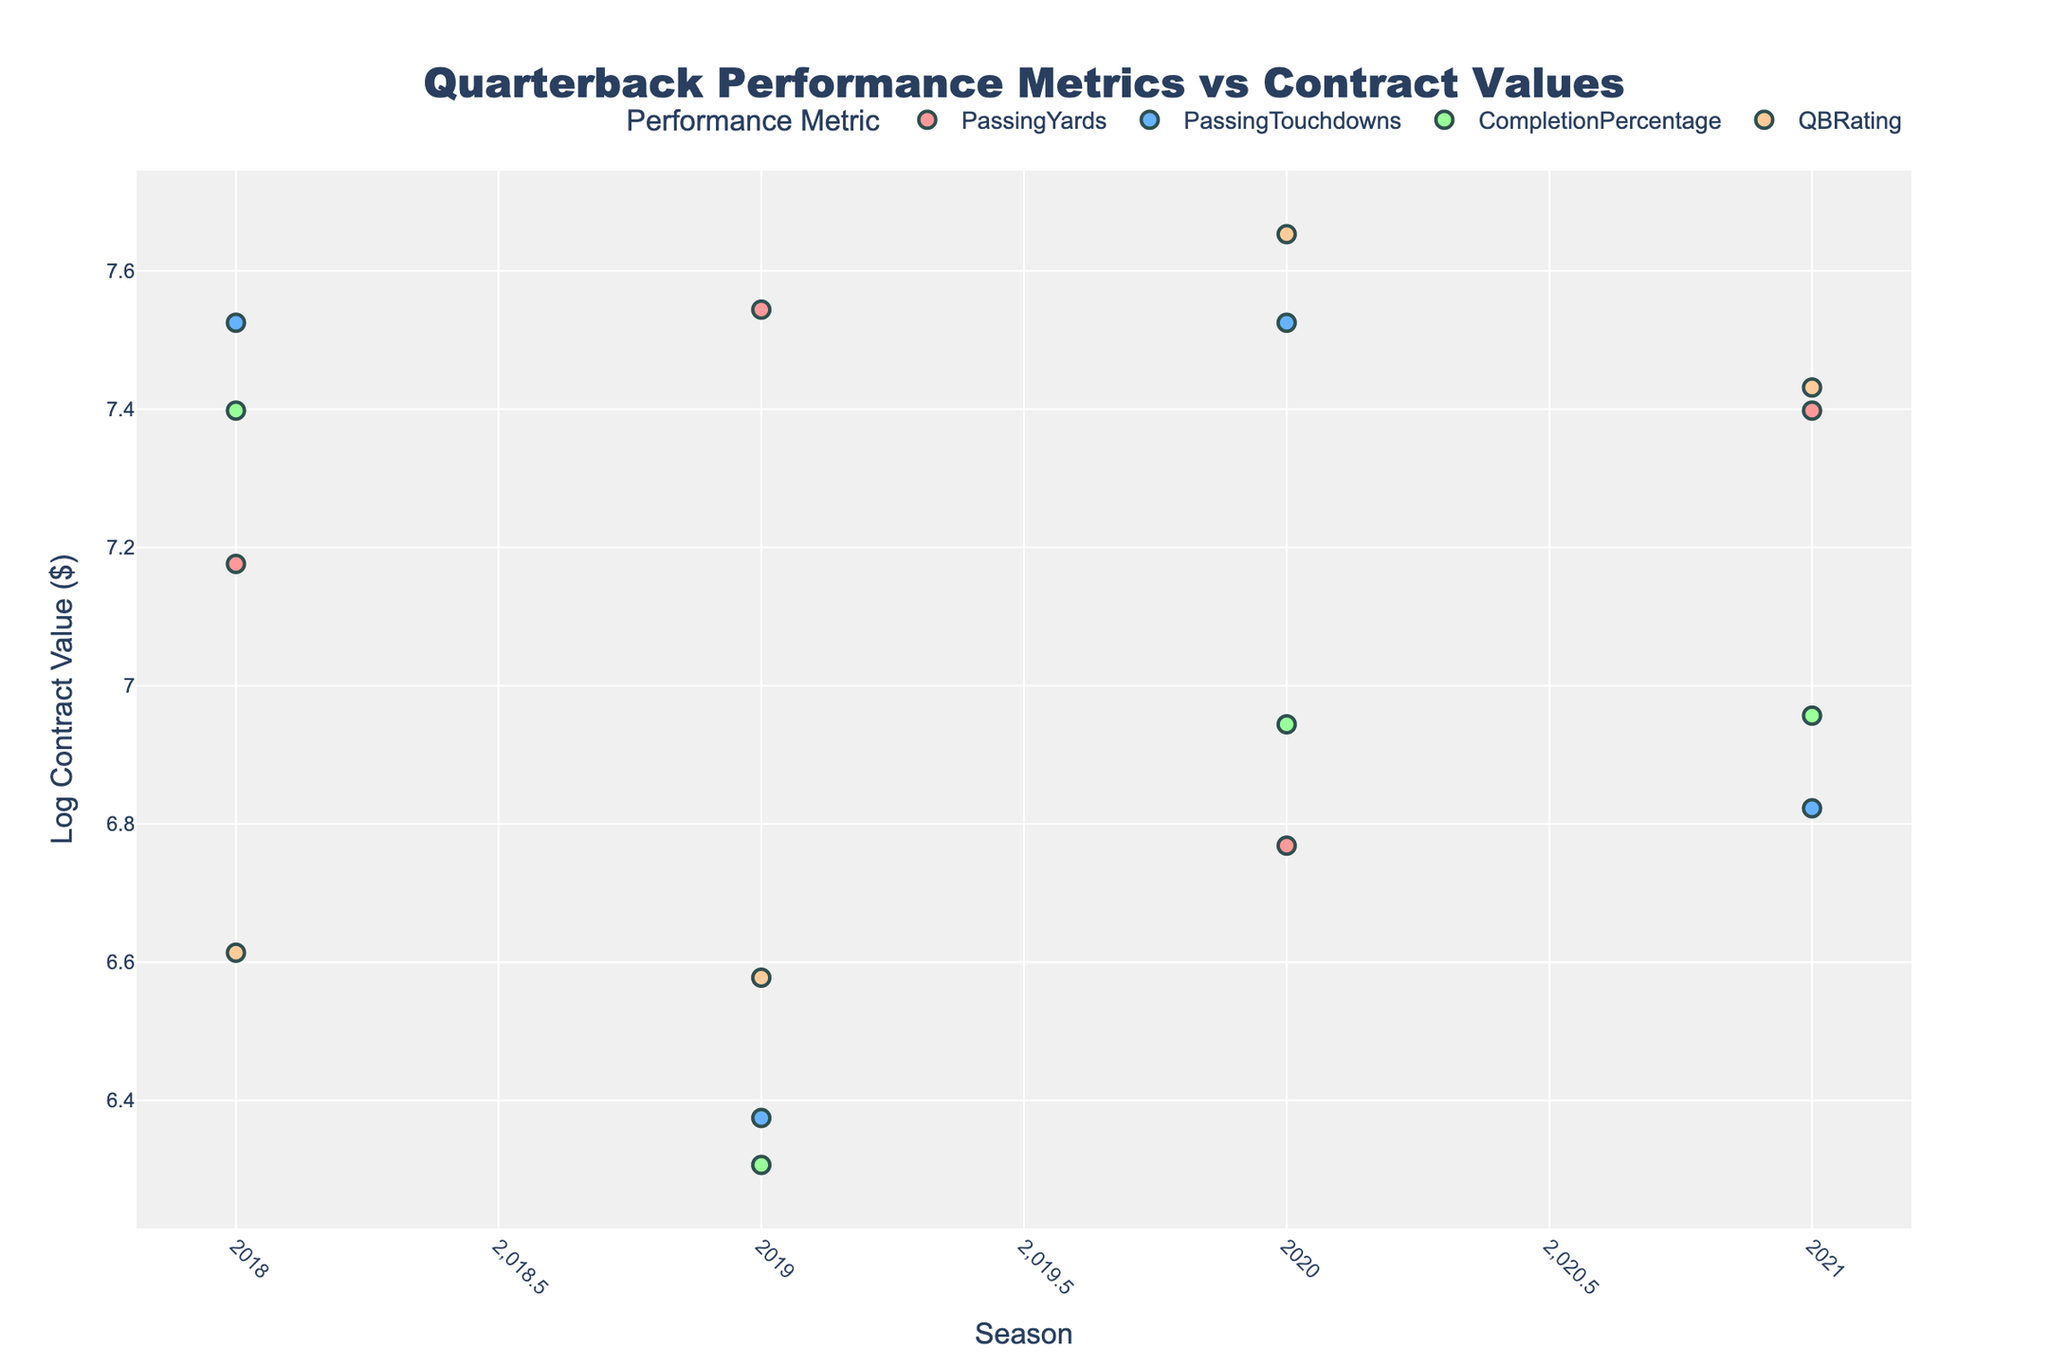What's the title of the plot? The title is located at the top center of the plot. It reads "Quarterback Performance Metrics vs Contract Values".
Answer: Quarterback Performance Metrics vs Contract Values How many different performance metrics are shown in the plot? Each unique performance metric is represented by different colors and markers. There are four distinct colors representing four metrics.
Answer: Four What metric is represented by the green markers? The green color in the plot legend indicates "CompletionPercentage".
Answer: CompletionPercentage Which player had the highest Log Contract Value in 2020? The highest Log Contract Value in 2020 is represented by the highest Y-coordinate in line with 2020 on the x-axis. Patrick Mahomes had the highest value.
Answer: Patrick Mahomes Which season has the most data points plotted? By counting the number of markers for each season along the x-axis, we see that 2020 has the most markers.
Answer: 2020 What's the log contract value for Tom Brady in the 2018 season? Locate Tom Brady's marker in 2018 and read the y-axis value. The log contract value is approximately 7.18.
Answer: ~7.18 How does the log contract value of Aaron Rodgers compare between 2018 and 2020? Find the y-coordinate values for Aaron Rodgers in both 2018 and 2020. They remain the same because his contract value didn't change between these years, both are approximately 7.52.
Answer: Same Calculate the average log contract value for the players in the 2021 season. Sum the log contract values of all players in the 2021 season and divide by the number of data points for 2021.
Answer: (7.40 + 6.82 + 6.95 + 7.43)/4 ≈ 7.15 Which performance metric has the lowest average log contract value across all seasons? Calculate the average log contract value for each metric by summing the values and dividing by the count, then compare them. "CompletionPercentage" has the lowest average log contract value.
Answer: CompletionPercentage Between Passing Touchdowns and QBRating, which metric has a higher log contract value on average? Calculate the average log contract value for the markers representing "PassingTouchdowns" and "QBRating", then compare. "PassingTouchdowns" has a higher average log contract value than "QBRating".
Answer: PassingTouchdowns 